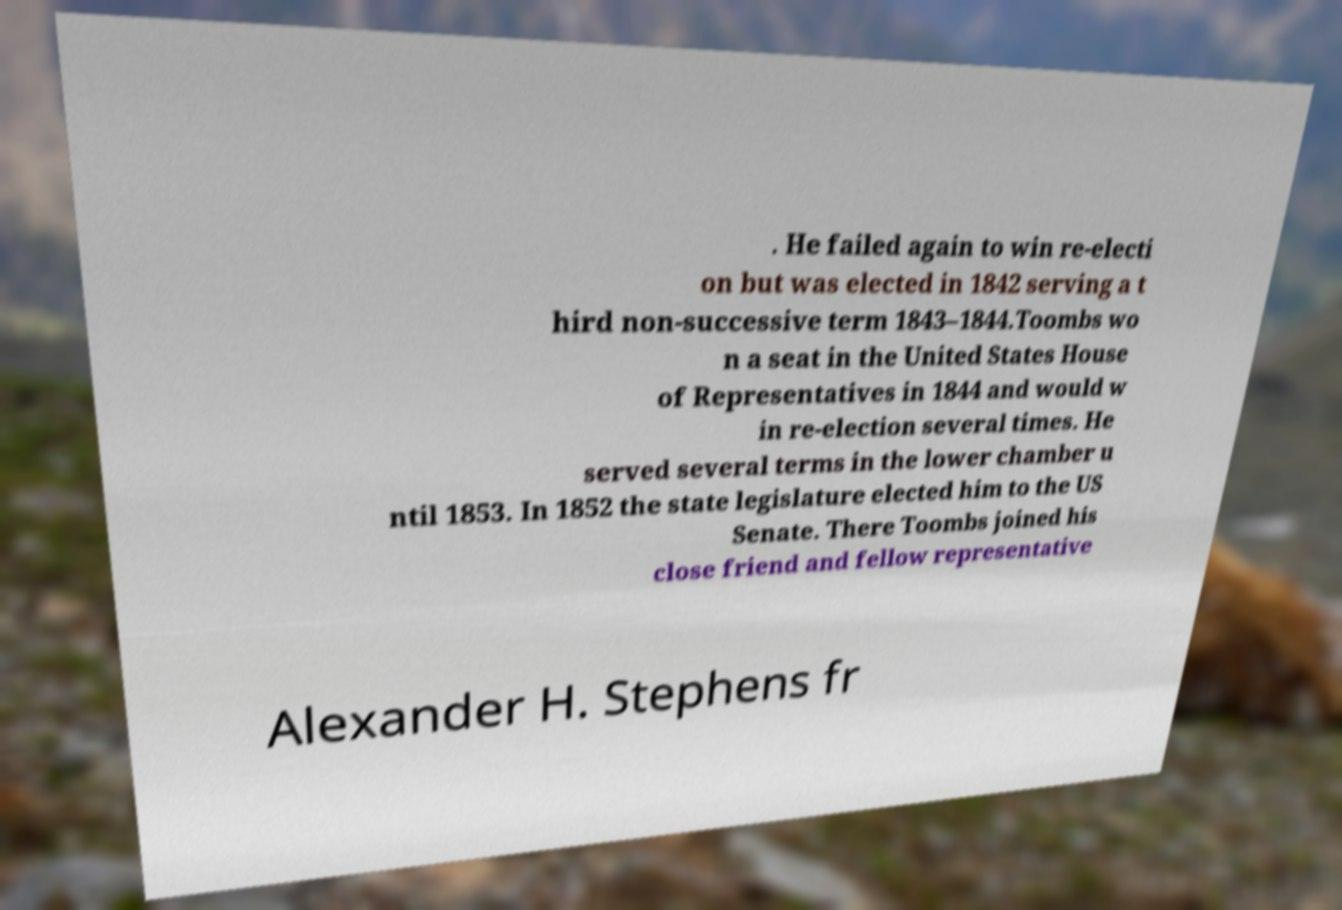For documentation purposes, I need the text within this image transcribed. Could you provide that? . He failed again to win re-electi on but was elected in 1842 serving a t hird non-successive term 1843–1844.Toombs wo n a seat in the United States House of Representatives in 1844 and would w in re-election several times. He served several terms in the lower chamber u ntil 1853. In 1852 the state legislature elected him to the US Senate. There Toombs joined his close friend and fellow representative Alexander H. Stephens fr 